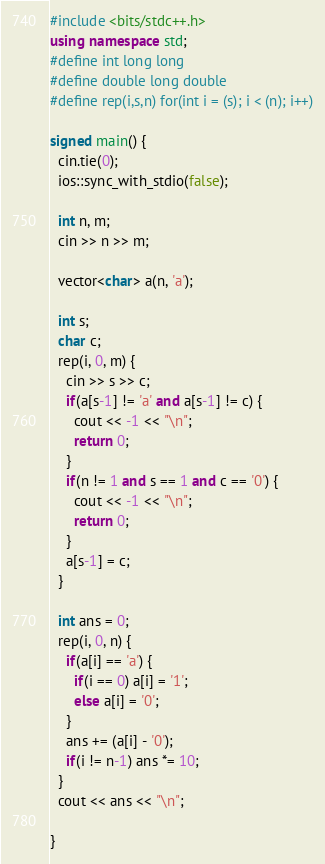<code> <loc_0><loc_0><loc_500><loc_500><_C++_>#include <bits/stdc++.h>
using namespace std;
#define int long long
#define double long double
#define rep(i,s,n) for(int i = (s); i < (n); i++)

signed main() {
  cin.tie(0);
  ios::sync_with_stdio(false);
  
  int n, m;
  cin >> n >> m;
  
  vector<char> a(n, 'a');  
  
  int s;
  char c;
  rep(i, 0, m) {
    cin >> s >> c;
    if(a[s-1] != 'a' and a[s-1] != c) {
      cout << -1 << "\n";
      return 0;
    }
    if(n != 1 and s == 1 and c == '0') {
      cout << -1 << "\n";
      return 0;
    }
    a[s-1] = c;
  }
  
  int ans = 0;
  rep(i, 0, n) {
    if(a[i] == 'a') {
      if(i == 0) a[i] = '1';
      else a[i] = '0';
    }
    ans += (a[i] - '0');
    if(i != n-1) ans *= 10;
  }
  cout << ans << "\n";

}</code> 